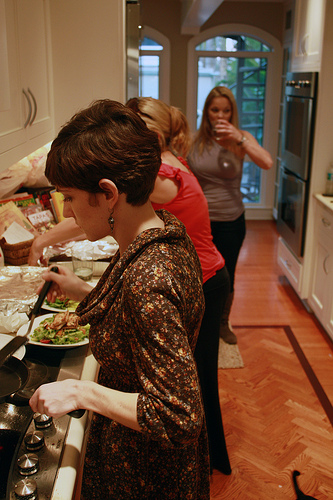Please provide a short description for this region: [0.19, 0.95, 0.24, 0.99]. Stove has a knob. This region captures a part of the stove featuring a control knob. 